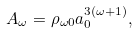<formula> <loc_0><loc_0><loc_500><loc_500>A _ { \omega } = \rho _ { \omega 0 } a _ { 0 } ^ { 3 ( \omega + 1 ) } ,</formula> 